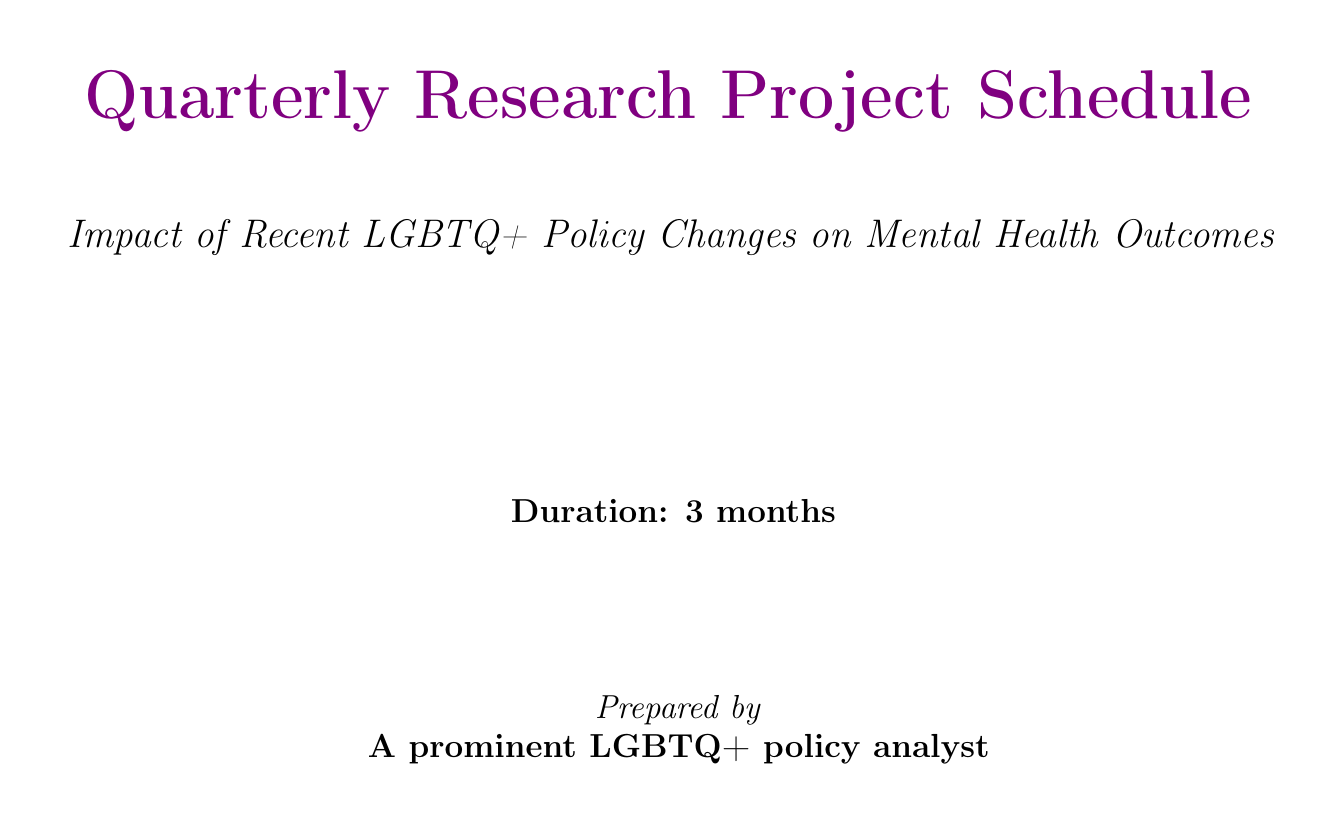What is the project title? The project title is stated in the document as "Impact of Recent LGBTQ+ Policy Changes on Mental Health Outcomes."
Answer: Impact of Recent LGBTQ+ Policy Changes on Mental Health Outcomes When is the literature review completion date? The literature review completion date is outlined as "Week 6."
Answer: Week 6 Who is responsible for the topic "Intersectionality in LGBTQ+ Health Outcomes"? The document assigns responsibility for this topic to the "Diversity and Inclusion Researcher."
Answer: Diversity and Inclusion Researcher What milestone occurs in Week 11? The document specifies that "Draft Report" is the milestone for Week 11.
Answer: Draft Report How often are the bi-weekly team check-ins scheduled? The frequency for bi-weekly team check-ins is stated as "Every other Monday."
Answer: Every other Monday What organization is consulted for mental health best practices? The document mentions the "American Psychological Association" as the organization consulted for this purpose.
Answer: American Psychological Association Which week is designated for data collection? The schedule indicates that data collection is set for "Week 9."
Answer: Week 9 What is the frequency of the Monthly Stakeholder Update? The frequency for the Monthly Stakeholder Update is stated as "Last Friday of each month."
Answer: Last Friday of each month In which week is the external consultation with the National LGBTQ Task Force scheduled? The document specifies that this consultation is scheduled for "Week 7."
Answer: Week 7 